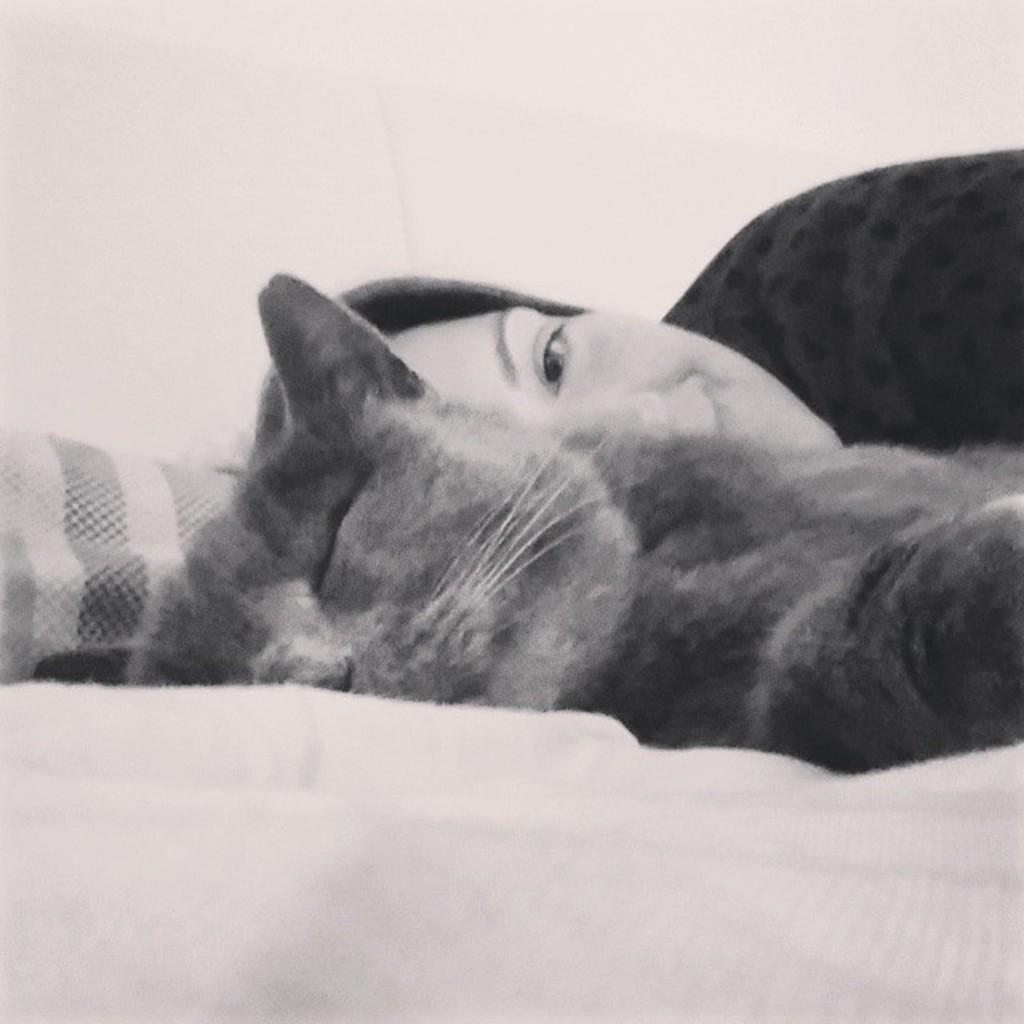How many individuals are present in the image? There is one person in the image. What other living creature is present in the image? There is an animal in the image. Where are the person and the animal located in the image? Both the person and the animal are on a bed. How does the person and the animal join together to form a single entity in the image? The person and the animal do not join together to form a single entity in the image; they are separate beings. 